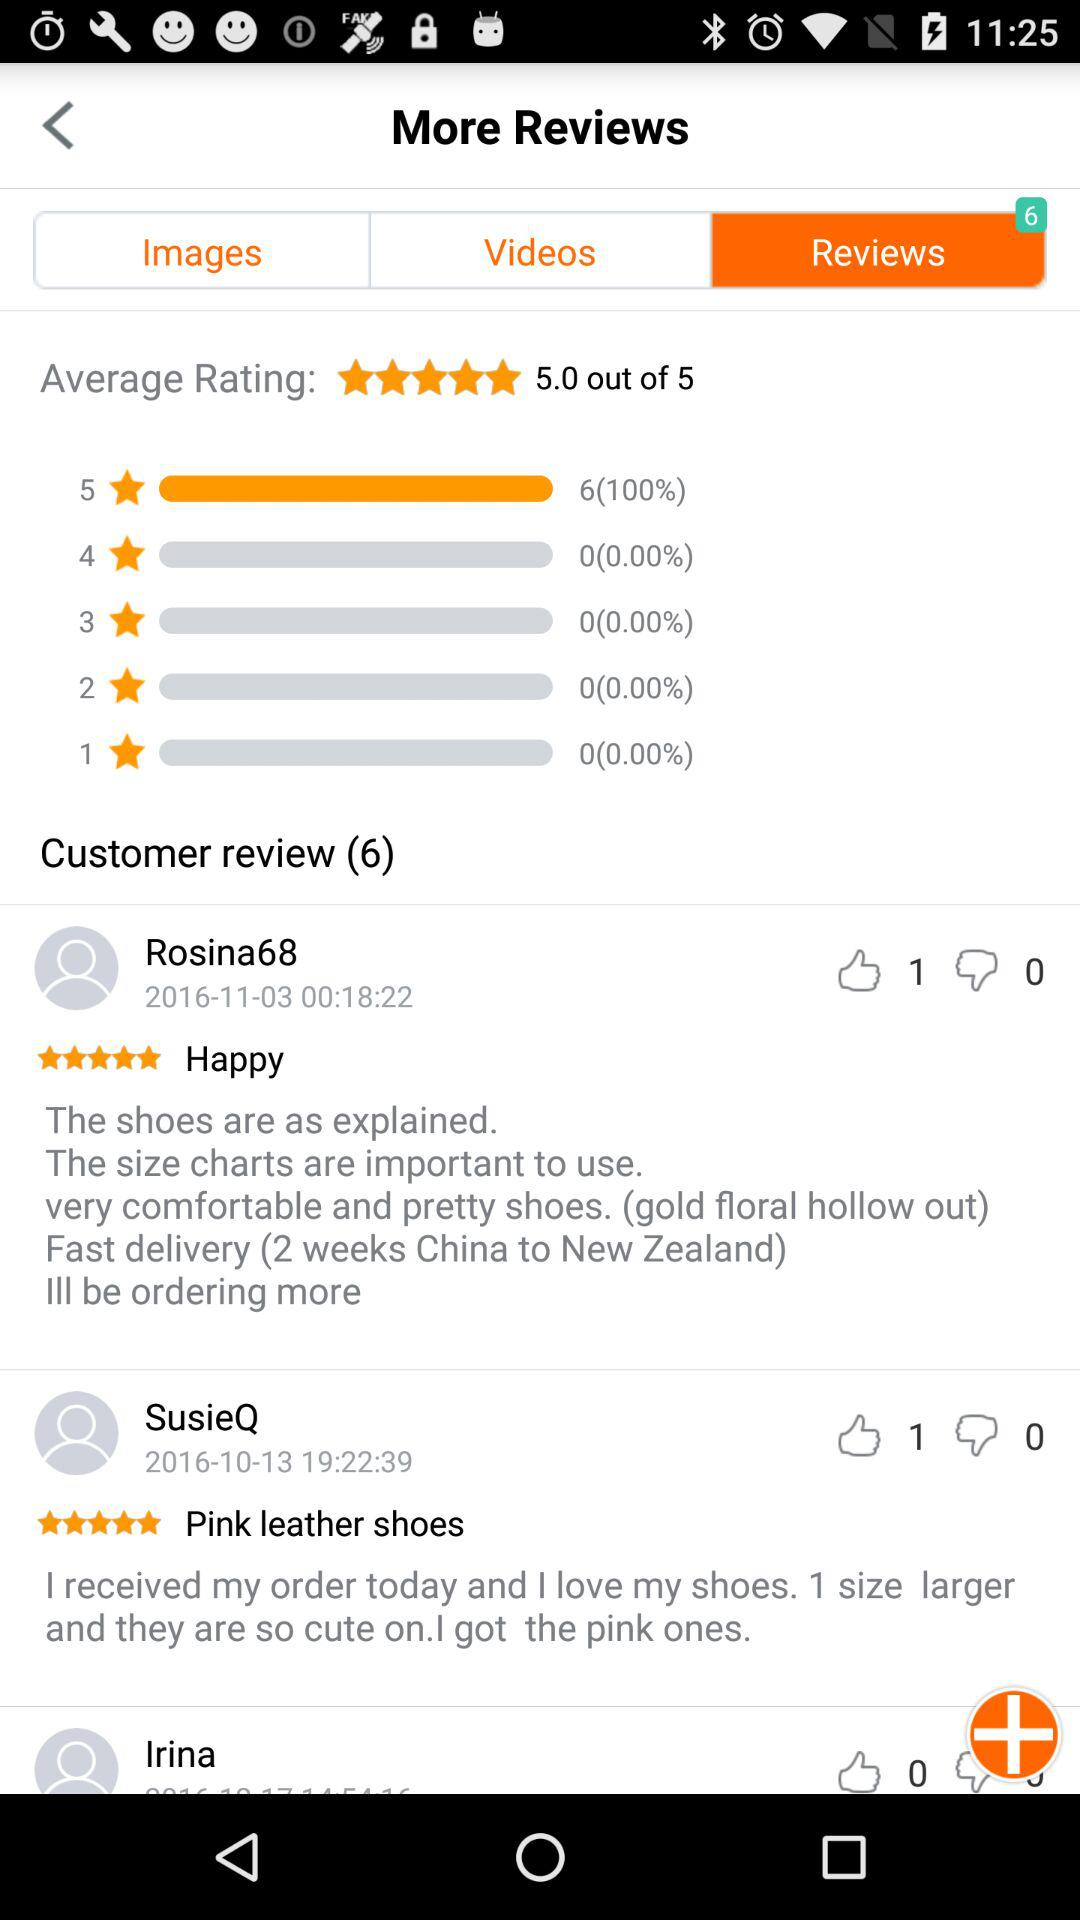How many new customer reviews are there? There are 6 new customer reviews. 